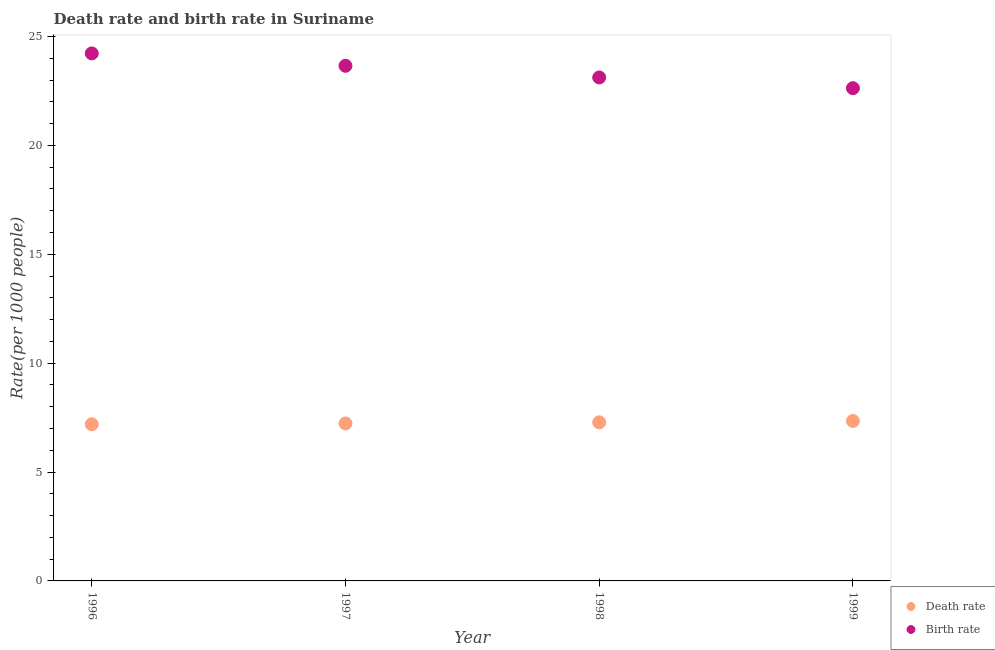What is the death rate in 1996?
Your answer should be compact. 7.2. Across all years, what is the maximum death rate?
Give a very brief answer. 7.35. Across all years, what is the minimum death rate?
Give a very brief answer. 7.2. In which year was the birth rate minimum?
Your answer should be very brief. 1999. What is the total death rate in the graph?
Offer a terse response. 29.06. What is the difference between the birth rate in 1996 and that in 1997?
Offer a very short reply. 0.57. What is the difference between the death rate in 1997 and the birth rate in 1999?
Provide a short and direct response. -15.4. What is the average birth rate per year?
Keep it short and to the point. 23.41. In the year 1996, what is the difference between the death rate and birth rate?
Your response must be concise. -17.03. In how many years, is the birth rate greater than 3?
Provide a short and direct response. 4. What is the ratio of the birth rate in 1996 to that in 1999?
Your answer should be compact. 1.07. Is the birth rate in 1996 less than that in 1999?
Your answer should be compact. No. What is the difference between the highest and the second highest death rate?
Your response must be concise. 0.06. What is the difference between the highest and the lowest birth rate?
Your answer should be very brief. 1.6. Is the death rate strictly less than the birth rate over the years?
Make the answer very short. Yes. How many dotlines are there?
Offer a terse response. 2. How many years are there in the graph?
Offer a very short reply. 4. Are the values on the major ticks of Y-axis written in scientific E-notation?
Provide a succinct answer. No. Does the graph contain any zero values?
Offer a very short reply. No. Where does the legend appear in the graph?
Make the answer very short. Bottom right. How are the legend labels stacked?
Offer a very short reply. Vertical. What is the title of the graph?
Offer a very short reply. Death rate and birth rate in Suriname. Does "Start a business" appear as one of the legend labels in the graph?
Keep it short and to the point. No. What is the label or title of the Y-axis?
Your response must be concise. Rate(per 1000 people). What is the Rate(per 1000 people) of Death rate in 1996?
Give a very brief answer. 7.2. What is the Rate(per 1000 people) of Birth rate in 1996?
Ensure brevity in your answer.  24.23. What is the Rate(per 1000 people) of Death rate in 1997?
Make the answer very short. 7.23. What is the Rate(per 1000 people) of Birth rate in 1997?
Your answer should be compact. 23.66. What is the Rate(per 1000 people) in Death rate in 1998?
Make the answer very short. 7.29. What is the Rate(per 1000 people) of Birth rate in 1998?
Your response must be concise. 23.12. What is the Rate(per 1000 people) in Death rate in 1999?
Provide a short and direct response. 7.35. What is the Rate(per 1000 people) in Birth rate in 1999?
Keep it short and to the point. 22.63. Across all years, what is the maximum Rate(per 1000 people) in Death rate?
Ensure brevity in your answer.  7.35. Across all years, what is the maximum Rate(per 1000 people) in Birth rate?
Your response must be concise. 24.23. Across all years, what is the minimum Rate(per 1000 people) of Death rate?
Make the answer very short. 7.2. Across all years, what is the minimum Rate(per 1000 people) of Birth rate?
Your answer should be compact. 22.63. What is the total Rate(per 1000 people) in Death rate in the graph?
Offer a very short reply. 29.06. What is the total Rate(per 1000 people) of Birth rate in the graph?
Keep it short and to the point. 93.64. What is the difference between the Rate(per 1000 people) of Death rate in 1996 and that in 1997?
Keep it short and to the point. -0.04. What is the difference between the Rate(per 1000 people) of Birth rate in 1996 and that in 1997?
Ensure brevity in your answer.  0.57. What is the difference between the Rate(per 1000 people) in Death rate in 1996 and that in 1998?
Your response must be concise. -0.09. What is the difference between the Rate(per 1000 people) of Birth rate in 1996 and that in 1998?
Provide a short and direct response. 1.1. What is the difference between the Rate(per 1000 people) in Death rate in 1996 and that in 1999?
Your answer should be compact. -0.15. What is the difference between the Rate(per 1000 people) in Birth rate in 1996 and that in 1999?
Your answer should be very brief. 1.6. What is the difference between the Rate(per 1000 people) of Death rate in 1997 and that in 1998?
Your answer should be very brief. -0.05. What is the difference between the Rate(per 1000 people) in Birth rate in 1997 and that in 1998?
Your answer should be compact. 0.54. What is the difference between the Rate(per 1000 people) of Death rate in 1997 and that in 1999?
Your answer should be compact. -0.11. What is the difference between the Rate(per 1000 people) in Birth rate in 1997 and that in 1999?
Provide a short and direct response. 1.03. What is the difference between the Rate(per 1000 people) in Death rate in 1998 and that in 1999?
Ensure brevity in your answer.  -0.06. What is the difference between the Rate(per 1000 people) of Birth rate in 1998 and that in 1999?
Provide a short and direct response. 0.49. What is the difference between the Rate(per 1000 people) of Death rate in 1996 and the Rate(per 1000 people) of Birth rate in 1997?
Your answer should be compact. -16.46. What is the difference between the Rate(per 1000 people) in Death rate in 1996 and the Rate(per 1000 people) in Birth rate in 1998?
Offer a terse response. -15.93. What is the difference between the Rate(per 1000 people) of Death rate in 1996 and the Rate(per 1000 people) of Birth rate in 1999?
Offer a terse response. -15.44. What is the difference between the Rate(per 1000 people) in Death rate in 1997 and the Rate(per 1000 people) in Birth rate in 1998?
Provide a short and direct response. -15.89. What is the difference between the Rate(per 1000 people) in Death rate in 1997 and the Rate(per 1000 people) in Birth rate in 1999?
Keep it short and to the point. -15.4. What is the difference between the Rate(per 1000 people) in Death rate in 1998 and the Rate(per 1000 people) in Birth rate in 1999?
Provide a short and direct response. -15.35. What is the average Rate(per 1000 people) of Death rate per year?
Your answer should be compact. 7.26. What is the average Rate(per 1000 people) in Birth rate per year?
Ensure brevity in your answer.  23.41. In the year 1996, what is the difference between the Rate(per 1000 people) in Death rate and Rate(per 1000 people) in Birth rate?
Your response must be concise. -17.03. In the year 1997, what is the difference between the Rate(per 1000 people) of Death rate and Rate(per 1000 people) of Birth rate?
Provide a short and direct response. -16.42. In the year 1998, what is the difference between the Rate(per 1000 people) of Death rate and Rate(per 1000 people) of Birth rate?
Provide a short and direct response. -15.84. In the year 1999, what is the difference between the Rate(per 1000 people) of Death rate and Rate(per 1000 people) of Birth rate?
Your answer should be compact. -15.28. What is the ratio of the Rate(per 1000 people) of Death rate in 1996 to that in 1997?
Keep it short and to the point. 0.99. What is the ratio of the Rate(per 1000 people) in Birth rate in 1996 to that in 1997?
Your response must be concise. 1.02. What is the ratio of the Rate(per 1000 people) in Death rate in 1996 to that in 1998?
Your response must be concise. 0.99. What is the ratio of the Rate(per 1000 people) of Birth rate in 1996 to that in 1998?
Provide a short and direct response. 1.05. What is the ratio of the Rate(per 1000 people) in Death rate in 1996 to that in 1999?
Give a very brief answer. 0.98. What is the ratio of the Rate(per 1000 people) of Birth rate in 1996 to that in 1999?
Offer a very short reply. 1.07. What is the ratio of the Rate(per 1000 people) of Birth rate in 1997 to that in 1998?
Your answer should be compact. 1.02. What is the ratio of the Rate(per 1000 people) in Death rate in 1997 to that in 1999?
Your answer should be compact. 0.98. What is the ratio of the Rate(per 1000 people) of Birth rate in 1997 to that in 1999?
Your answer should be compact. 1.05. What is the ratio of the Rate(per 1000 people) in Birth rate in 1998 to that in 1999?
Your answer should be very brief. 1.02. What is the difference between the highest and the second highest Rate(per 1000 people) of Death rate?
Your answer should be very brief. 0.06. What is the difference between the highest and the second highest Rate(per 1000 people) in Birth rate?
Your response must be concise. 0.57. What is the difference between the highest and the lowest Rate(per 1000 people) of Death rate?
Your answer should be very brief. 0.15. What is the difference between the highest and the lowest Rate(per 1000 people) of Birth rate?
Ensure brevity in your answer.  1.6. 